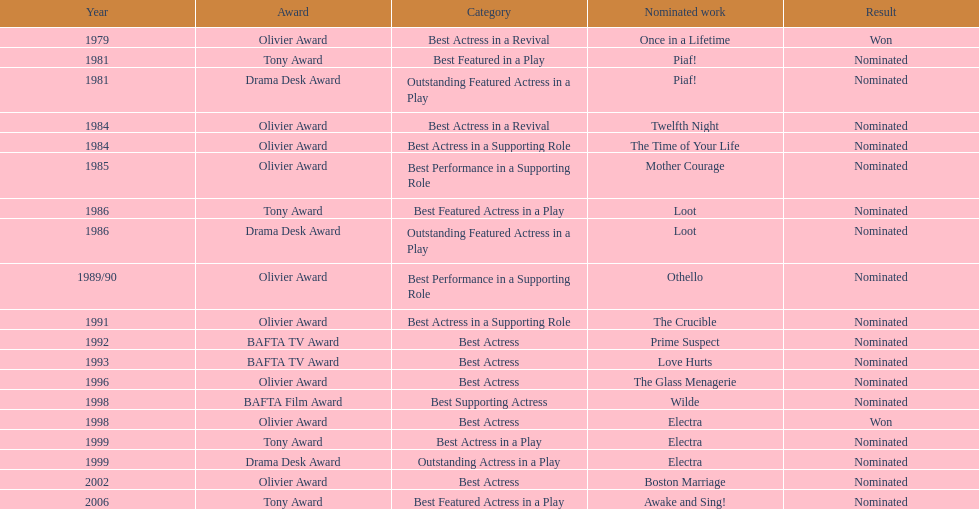Which accolade was received by "once in a lifetime"? Best Actress in a Revival. 